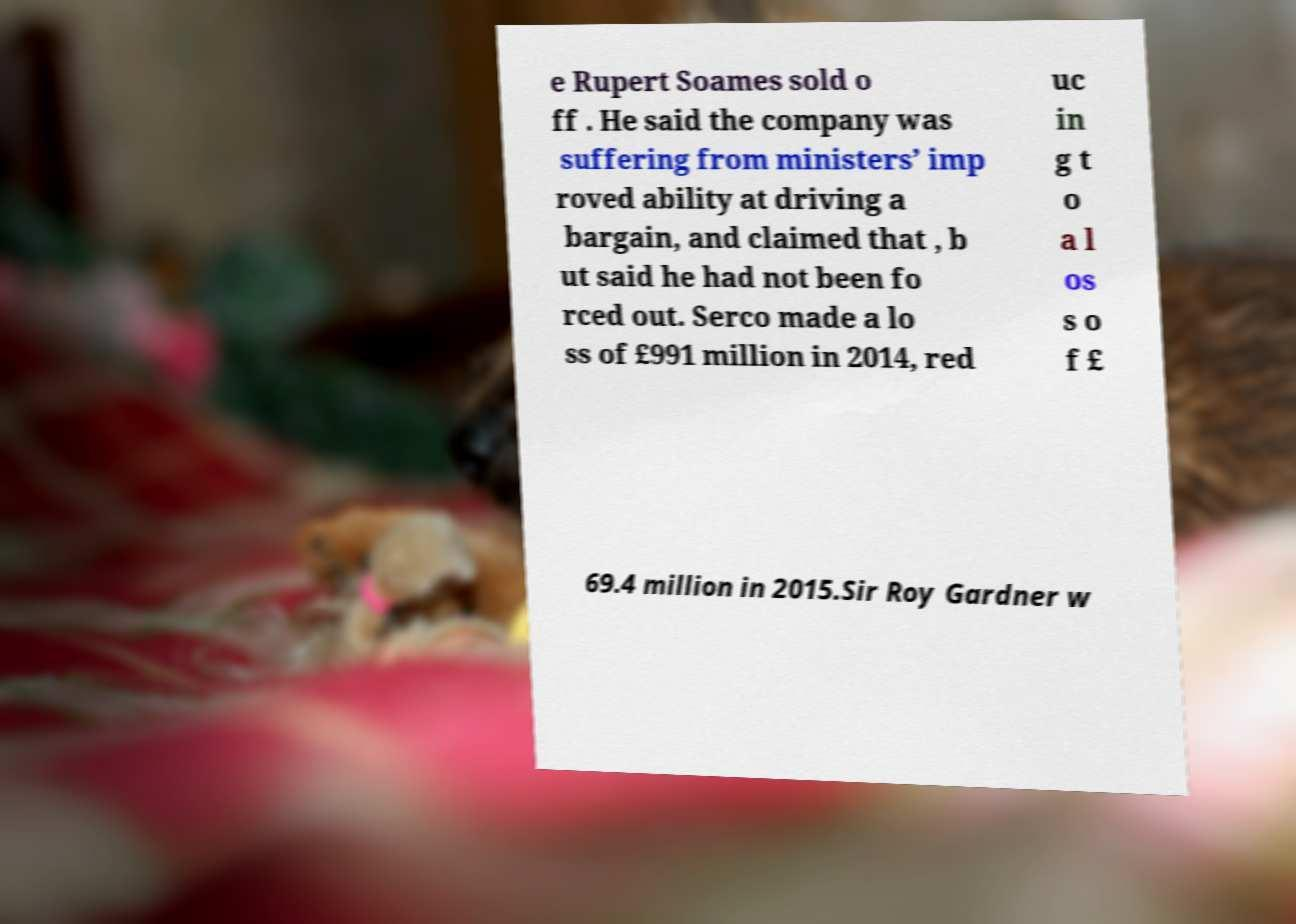Please identify and transcribe the text found in this image. e Rupert Soames sold o ff . He said the company was suffering from ministers’ imp roved ability at driving a bargain, and claimed that , b ut said he had not been fo rced out. Serco made a lo ss of £991 million in 2014, red uc in g t o a l os s o f £ 69.4 million in 2015.Sir Roy Gardner w 